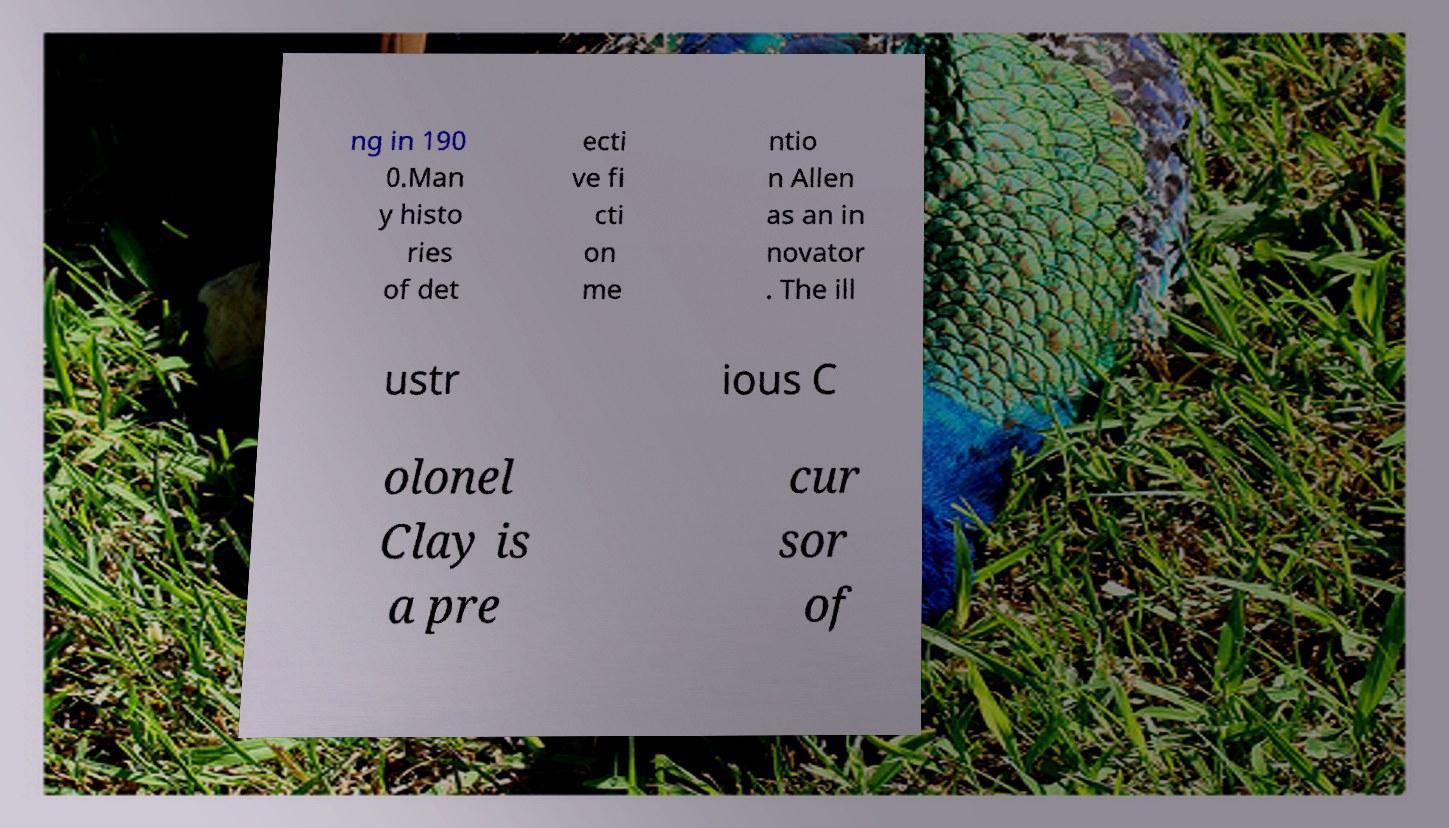Please read and relay the text visible in this image. What does it say? ng in 190 0.Man y histo ries of det ecti ve fi cti on me ntio n Allen as an in novator . The ill ustr ious C olonel Clay is a pre cur sor of 